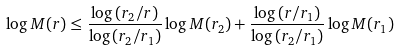Convert formula to latex. <formula><loc_0><loc_0><loc_500><loc_500>\log M ( r ) \leq \frac { \log \left ( r _ { 2 } / r \right ) } { \log \left ( r _ { 2 } / r _ { 1 } \right ) } \log M ( r _ { 2 } ) + \frac { \log \left ( r / r _ { 1 } \right ) } { \log \left ( r _ { 2 } / r _ { 1 } \right ) } \log M ( r _ { 1 } )</formula> 